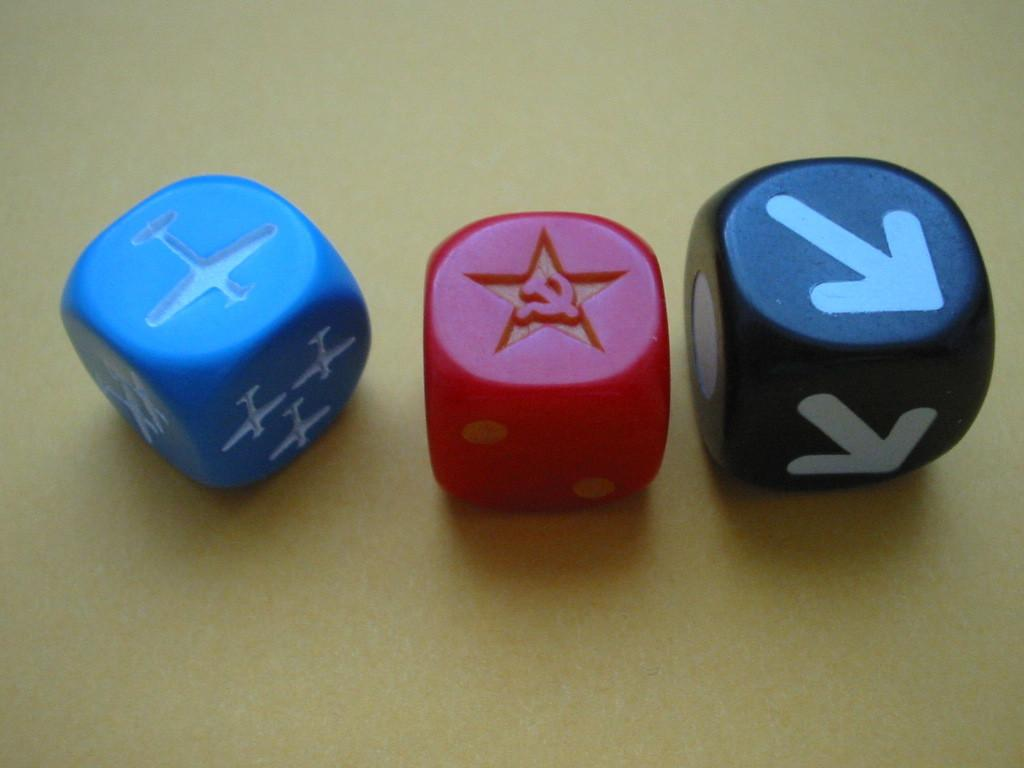How many dice are present in the image? There are 3 dice in the image. What colors are the dice in the image? The dice are in black, red, and blue colors. How does the respect for the jellyfish manifest in the image? There is no jellyfish present in the image, and therefore no such interaction can be observed. Is there a volcano visible in the image? There is no volcano present in the image. 